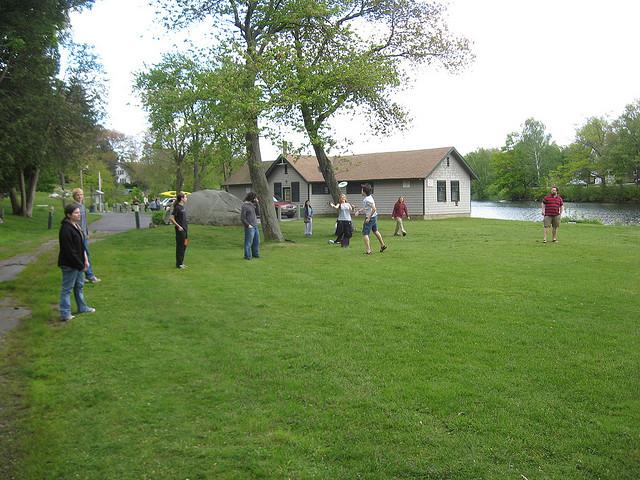What are these houses made of?
Be succinct. Wood. What is the boy in the orange jacket holding?
Write a very short answer. Nothing. How many people have red shirts?
Concise answer only. 2. How many people are walking?
Write a very short answer. 3. How many buildings are visible?
Quick response, please. 1. Is there a body of water in this picture?
Write a very short answer. Yes. 